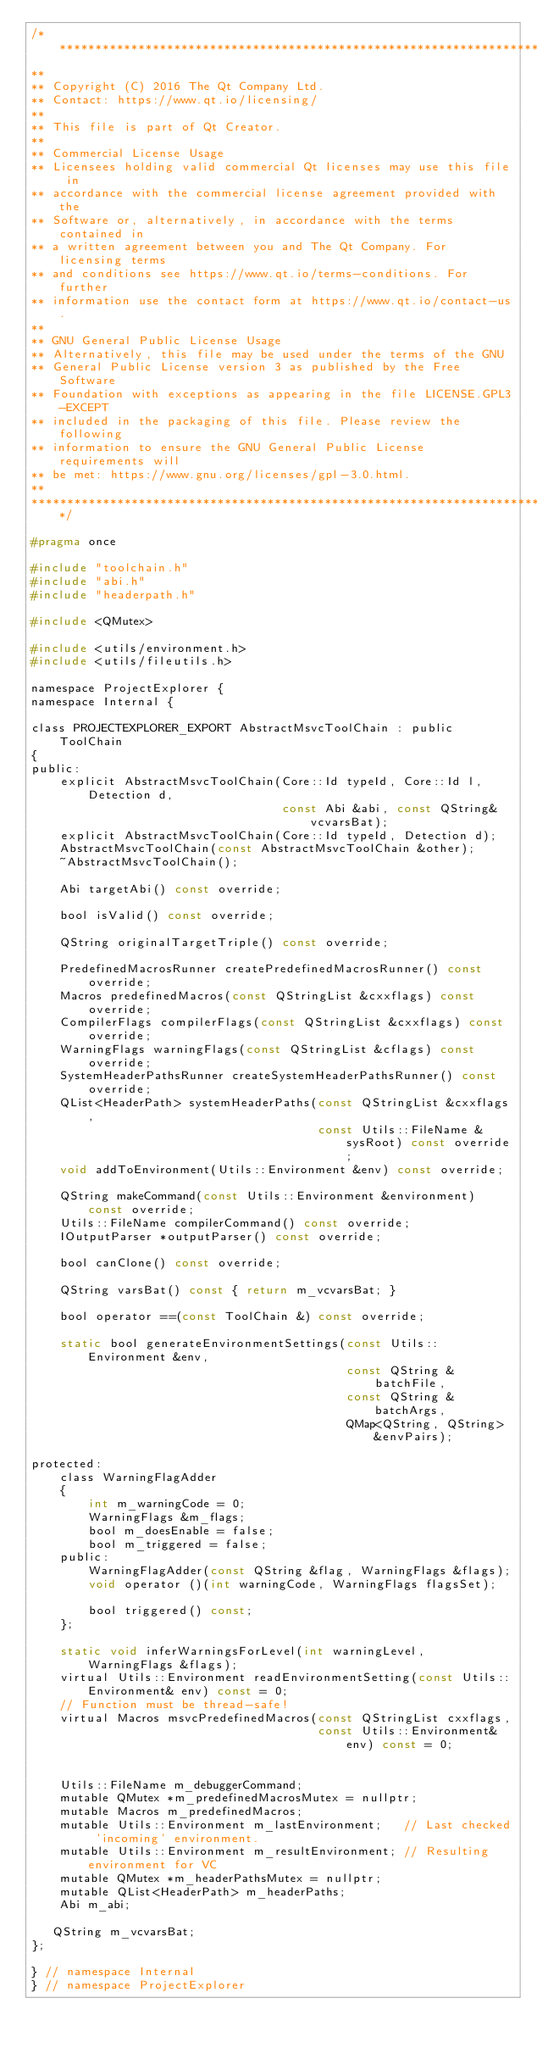Convert code to text. <code><loc_0><loc_0><loc_500><loc_500><_C_>/****************************************************************************
**
** Copyright (C) 2016 The Qt Company Ltd.
** Contact: https://www.qt.io/licensing/
**
** This file is part of Qt Creator.
**
** Commercial License Usage
** Licensees holding valid commercial Qt licenses may use this file in
** accordance with the commercial license agreement provided with the
** Software or, alternatively, in accordance with the terms contained in
** a written agreement between you and The Qt Company. For licensing terms
** and conditions see https://www.qt.io/terms-conditions. For further
** information use the contact form at https://www.qt.io/contact-us.
**
** GNU General Public License Usage
** Alternatively, this file may be used under the terms of the GNU
** General Public License version 3 as published by the Free Software
** Foundation with exceptions as appearing in the file LICENSE.GPL3-EXCEPT
** included in the packaging of this file. Please review the following
** information to ensure the GNU General Public License requirements will
** be met: https://www.gnu.org/licenses/gpl-3.0.html.
**
****************************************************************************/

#pragma once

#include "toolchain.h"
#include "abi.h"
#include "headerpath.h"

#include <QMutex>

#include <utils/environment.h>
#include <utils/fileutils.h>

namespace ProjectExplorer {
namespace Internal {

class PROJECTEXPLORER_EXPORT AbstractMsvcToolChain : public ToolChain
{
public:
    explicit AbstractMsvcToolChain(Core::Id typeId, Core::Id l, Detection d,
                                   const Abi &abi, const QString& vcvarsBat);
    explicit AbstractMsvcToolChain(Core::Id typeId, Detection d);
    AbstractMsvcToolChain(const AbstractMsvcToolChain &other);
    ~AbstractMsvcToolChain();

    Abi targetAbi() const override;

    bool isValid() const override;

    QString originalTargetTriple() const override;

    PredefinedMacrosRunner createPredefinedMacrosRunner() const override;
    Macros predefinedMacros(const QStringList &cxxflags) const override;
    CompilerFlags compilerFlags(const QStringList &cxxflags) const override;
    WarningFlags warningFlags(const QStringList &cflags) const override;
    SystemHeaderPathsRunner createSystemHeaderPathsRunner() const override;
    QList<HeaderPath> systemHeaderPaths(const QStringList &cxxflags,
                                        const Utils::FileName &sysRoot) const override;
    void addToEnvironment(Utils::Environment &env) const override;

    QString makeCommand(const Utils::Environment &environment) const override;
    Utils::FileName compilerCommand() const override;
    IOutputParser *outputParser() const override;

    bool canClone() const override;

    QString varsBat() const { return m_vcvarsBat; }

    bool operator ==(const ToolChain &) const override;

    static bool generateEnvironmentSettings(const Utils::Environment &env,
                                            const QString &batchFile,
                                            const QString &batchArgs,
                                            QMap<QString, QString> &envPairs);

protected:
    class WarningFlagAdder
    {
        int m_warningCode = 0;
        WarningFlags &m_flags;
        bool m_doesEnable = false;
        bool m_triggered = false;
    public:
        WarningFlagAdder(const QString &flag, WarningFlags &flags);
        void operator ()(int warningCode, WarningFlags flagsSet);

        bool triggered() const;
    };

    static void inferWarningsForLevel(int warningLevel, WarningFlags &flags);
    virtual Utils::Environment readEnvironmentSetting(const Utils::Environment& env) const = 0;
    // Function must be thread-safe!
    virtual Macros msvcPredefinedMacros(const QStringList cxxflags,
                                        const Utils::Environment& env) const = 0;


    Utils::FileName m_debuggerCommand;
    mutable QMutex *m_predefinedMacrosMutex = nullptr;
    mutable Macros m_predefinedMacros;
    mutable Utils::Environment m_lastEnvironment;   // Last checked 'incoming' environment.
    mutable Utils::Environment m_resultEnvironment; // Resulting environment for VC
    mutable QMutex *m_headerPathsMutex = nullptr;
    mutable QList<HeaderPath> m_headerPaths;
    Abi m_abi;

   QString m_vcvarsBat;
};

} // namespace Internal
} // namespace ProjectExplorer
</code> 